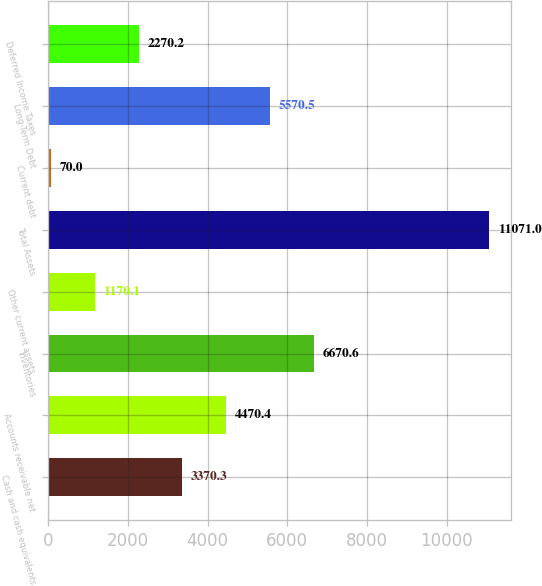Convert chart. <chart><loc_0><loc_0><loc_500><loc_500><bar_chart><fcel>Cash and cash equivalents<fcel>Accounts receivable net<fcel>Inventories<fcel>Other current assets<fcel>Total Assets<fcel>Current debt<fcel>Long-Term Debt<fcel>Deferred Income Taxes<nl><fcel>3370.3<fcel>4470.4<fcel>6670.6<fcel>1170.1<fcel>11071<fcel>70<fcel>5570.5<fcel>2270.2<nl></chart> 